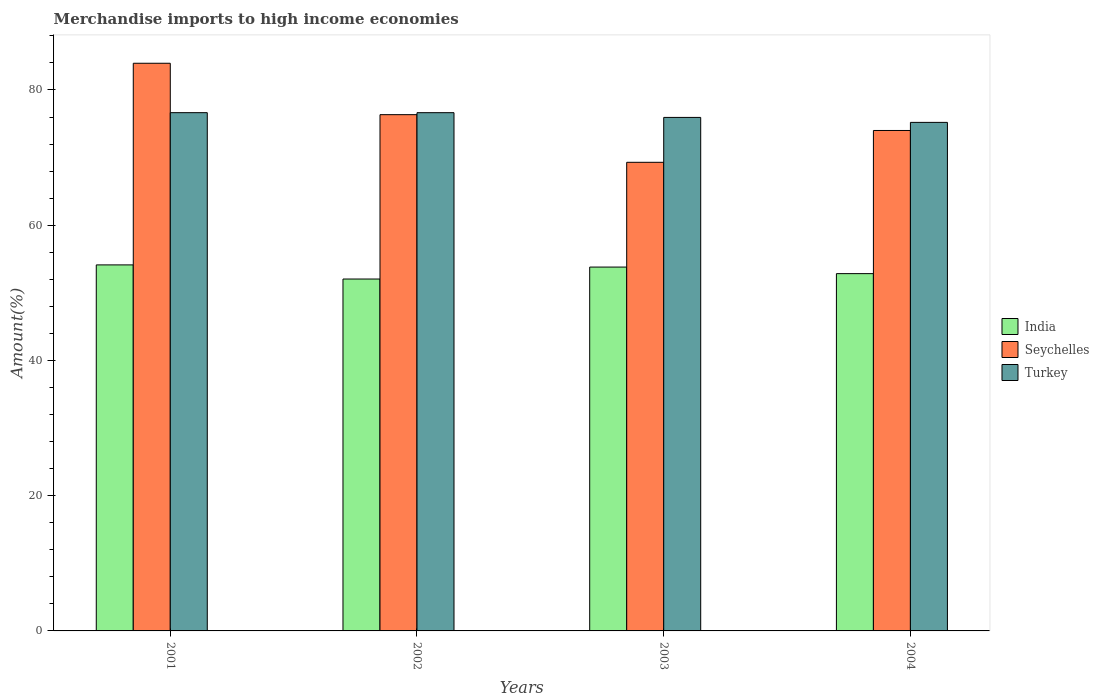How many different coloured bars are there?
Give a very brief answer. 3. How many groups of bars are there?
Provide a succinct answer. 4. How many bars are there on the 4th tick from the right?
Your response must be concise. 3. In how many cases, is the number of bars for a given year not equal to the number of legend labels?
Offer a very short reply. 0. What is the percentage of amount earned from merchandise imports in Turkey in 2001?
Offer a terse response. 76.65. Across all years, what is the maximum percentage of amount earned from merchandise imports in Turkey?
Ensure brevity in your answer.  76.65. Across all years, what is the minimum percentage of amount earned from merchandise imports in Seychelles?
Offer a very short reply. 69.31. In which year was the percentage of amount earned from merchandise imports in Turkey maximum?
Keep it short and to the point. 2001. What is the total percentage of amount earned from merchandise imports in Seychelles in the graph?
Offer a very short reply. 303.63. What is the difference between the percentage of amount earned from merchandise imports in Turkey in 2001 and that in 2004?
Ensure brevity in your answer.  1.44. What is the difference between the percentage of amount earned from merchandise imports in Turkey in 2002 and the percentage of amount earned from merchandise imports in India in 2004?
Your response must be concise. 23.81. What is the average percentage of amount earned from merchandise imports in Seychelles per year?
Make the answer very short. 75.91. In the year 2004, what is the difference between the percentage of amount earned from merchandise imports in Seychelles and percentage of amount earned from merchandise imports in India?
Give a very brief answer. 21.17. In how many years, is the percentage of amount earned from merchandise imports in Seychelles greater than 44 %?
Give a very brief answer. 4. What is the ratio of the percentage of amount earned from merchandise imports in India in 2001 to that in 2002?
Give a very brief answer. 1.04. Is the difference between the percentage of amount earned from merchandise imports in Seychelles in 2001 and 2002 greater than the difference between the percentage of amount earned from merchandise imports in India in 2001 and 2002?
Offer a very short reply. Yes. What is the difference between the highest and the second highest percentage of amount earned from merchandise imports in India?
Your answer should be compact. 0.32. What is the difference between the highest and the lowest percentage of amount earned from merchandise imports in India?
Provide a short and direct response. 2.09. In how many years, is the percentage of amount earned from merchandise imports in Turkey greater than the average percentage of amount earned from merchandise imports in Turkey taken over all years?
Make the answer very short. 2. Is the sum of the percentage of amount earned from merchandise imports in Seychelles in 2002 and 2004 greater than the maximum percentage of amount earned from merchandise imports in India across all years?
Offer a terse response. Yes. Is it the case that in every year, the sum of the percentage of amount earned from merchandise imports in Turkey and percentage of amount earned from merchandise imports in Seychelles is greater than the percentage of amount earned from merchandise imports in India?
Your answer should be very brief. Yes. How many bars are there?
Provide a succinct answer. 12. What is the difference between two consecutive major ticks on the Y-axis?
Your response must be concise. 20. Does the graph contain any zero values?
Your answer should be very brief. No. How are the legend labels stacked?
Give a very brief answer. Vertical. What is the title of the graph?
Your response must be concise. Merchandise imports to high income economies. What is the label or title of the Y-axis?
Provide a short and direct response. Amount(%). What is the Amount(%) in India in 2001?
Provide a short and direct response. 54.13. What is the Amount(%) in Seychelles in 2001?
Provide a succinct answer. 83.95. What is the Amount(%) of Turkey in 2001?
Keep it short and to the point. 76.65. What is the Amount(%) in India in 2002?
Ensure brevity in your answer.  52.04. What is the Amount(%) in Seychelles in 2002?
Provide a short and direct response. 76.35. What is the Amount(%) in Turkey in 2002?
Give a very brief answer. 76.65. What is the Amount(%) in India in 2003?
Provide a succinct answer. 53.81. What is the Amount(%) in Seychelles in 2003?
Your response must be concise. 69.31. What is the Amount(%) of Turkey in 2003?
Offer a very short reply. 75.95. What is the Amount(%) in India in 2004?
Ensure brevity in your answer.  52.84. What is the Amount(%) of Seychelles in 2004?
Offer a terse response. 74.01. What is the Amount(%) of Turkey in 2004?
Your answer should be very brief. 75.21. Across all years, what is the maximum Amount(%) in India?
Ensure brevity in your answer.  54.13. Across all years, what is the maximum Amount(%) of Seychelles?
Your answer should be compact. 83.95. Across all years, what is the maximum Amount(%) in Turkey?
Your answer should be very brief. 76.65. Across all years, what is the minimum Amount(%) in India?
Provide a short and direct response. 52.04. Across all years, what is the minimum Amount(%) in Seychelles?
Keep it short and to the point. 69.31. Across all years, what is the minimum Amount(%) of Turkey?
Keep it short and to the point. 75.21. What is the total Amount(%) of India in the graph?
Keep it short and to the point. 212.83. What is the total Amount(%) of Seychelles in the graph?
Make the answer very short. 303.63. What is the total Amount(%) in Turkey in the graph?
Ensure brevity in your answer.  304.45. What is the difference between the Amount(%) of India in 2001 and that in 2002?
Your response must be concise. 2.09. What is the difference between the Amount(%) in Seychelles in 2001 and that in 2002?
Offer a very short reply. 7.6. What is the difference between the Amount(%) in Turkey in 2001 and that in 2002?
Provide a succinct answer. 0. What is the difference between the Amount(%) in India in 2001 and that in 2003?
Your answer should be very brief. 0.32. What is the difference between the Amount(%) in Seychelles in 2001 and that in 2003?
Provide a short and direct response. 14.65. What is the difference between the Amount(%) in Turkey in 2001 and that in 2003?
Offer a terse response. 0.7. What is the difference between the Amount(%) of India in 2001 and that in 2004?
Keep it short and to the point. 1.29. What is the difference between the Amount(%) in Seychelles in 2001 and that in 2004?
Your answer should be very brief. 9.94. What is the difference between the Amount(%) in Turkey in 2001 and that in 2004?
Keep it short and to the point. 1.44. What is the difference between the Amount(%) in India in 2002 and that in 2003?
Offer a very short reply. -1.77. What is the difference between the Amount(%) in Seychelles in 2002 and that in 2003?
Offer a terse response. 7.05. What is the difference between the Amount(%) of Turkey in 2002 and that in 2003?
Your response must be concise. 0.7. What is the difference between the Amount(%) in India in 2002 and that in 2004?
Your response must be concise. -0.8. What is the difference between the Amount(%) of Seychelles in 2002 and that in 2004?
Give a very brief answer. 2.34. What is the difference between the Amount(%) of Turkey in 2002 and that in 2004?
Your answer should be very brief. 1.44. What is the difference between the Amount(%) in India in 2003 and that in 2004?
Provide a succinct answer. 0.97. What is the difference between the Amount(%) of Seychelles in 2003 and that in 2004?
Your answer should be compact. -4.71. What is the difference between the Amount(%) in Turkey in 2003 and that in 2004?
Offer a very short reply. 0.74. What is the difference between the Amount(%) of India in 2001 and the Amount(%) of Seychelles in 2002?
Keep it short and to the point. -22.22. What is the difference between the Amount(%) in India in 2001 and the Amount(%) in Turkey in 2002?
Offer a terse response. -22.51. What is the difference between the Amount(%) in Seychelles in 2001 and the Amount(%) in Turkey in 2002?
Keep it short and to the point. 7.31. What is the difference between the Amount(%) of India in 2001 and the Amount(%) of Seychelles in 2003?
Ensure brevity in your answer.  -15.17. What is the difference between the Amount(%) of India in 2001 and the Amount(%) of Turkey in 2003?
Your answer should be compact. -21.81. What is the difference between the Amount(%) in Seychelles in 2001 and the Amount(%) in Turkey in 2003?
Keep it short and to the point. 8.01. What is the difference between the Amount(%) of India in 2001 and the Amount(%) of Seychelles in 2004?
Give a very brief answer. -19.88. What is the difference between the Amount(%) in India in 2001 and the Amount(%) in Turkey in 2004?
Provide a short and direct response. -21.08. What is the difference between the Amount(%) of Seychelles in 2001 and the Amount(%) of Turkey in 2004?
Make the answer very short. 8.74. What is the difference between the Amount(%) in India in 2002 and the Amount(%) in Seychelles in 2003?
Make the answer very short. -17.26. What is the difference between the Amount(%) in India in 2002 and the Amount(%) in Turkey in 2003?
Offer a terse response. -23.9. What is the difference between the Amount(%) in Seychelles in 2002 and the Amount(%) in Turkey in 2003?
Offer a very short reply. 0.41. What is the difference between the Amount(%) in India in 2002 and the Amount(%) in Seychelles in 2004?
Keep it short and to the point. -21.97. What is the difference between the Amount(%) in India in 2002 and the Amount(%) in Turkey in 2004?
Offer a very short reply. -23.16. What is the difference between the Amount(%) of Seychelles in 2002 and the Amount(%) of Turkey in 2004?
Provide a short and direct response. 1.14. What is the difference between the Amount(%) of India in 2003 and the Amount(%) of Seychelles in 2004?
Give a very brief answer. -20.2. What is the difference between the Amount(%) in India in 2003 and the Amount(%) in Turkey in 2004?
Offer a terse response. -21.4. What is the difference between the Amount(%) in Seychelles in 2003 and the Amount(%) in Turkey in 2004?
Give a very brief answer. -5.9. What is the average Amount(%) in India per year?
Provide a short and direct response. 53.21. What is the average Amount(%) of Seychelles per year?
Your answer should be very brief. 75.91. What is the average Amount(%) of Turkey per year?
Offer a terse response. 76.11. In the year 2001, what is the difference between the Amount(%) in India and Amount(%) in Seychelles?
Give a very brief answer. -29.82. In the year 2001, what is the difference between the Amount(%) of India and Amount(%) of Turkey?
Your answer should be very brief. -22.52. In the year 2001, what is the difference between the Amount(%) of Seychelles and Amount(%) of Turkey?
Provide a succinct answer. 7.31. In the year 2002, what is the difference between the Amount(%) in India and Amount(%) in Seychelles?
Make the answer very short. -24.31. In the year 2002, what is the difference between the Amount(%) of India and Amount(%) of Turkey?
Give a very brief answer. -24.6. In the year 2002, what is the difference between the Amount(%) in Seychelles and Amount(%) in Turkey?
Give a very brief answer. -0.29. In the year 2003, what is the difference between the Amount(%) of India and Amount(%) of Seychelles?
Give a very brief answer. -15.49. In the year 2003, what is the difference between the Amount(%) in India and Amount(%) in Turkey?
Your answer should be compact. -22.13. In the year 2003, what is the difference between the Amount(%) of Seychelles and Amount(%) of Turkey?
Provide a short and direct response. -6.64. In the year 2004, what is the difference between the Amount(%) in India and Amount(%) in Seychelles?
Your answer should be very brief. -21.17. In the year 2004, what is the difference between the Amount(%) of India and Amount(%) of Turkey?
Ensure brevity in your answer.  -22.37. In the year 2004, what is the difference between the Amount(%) in Seychelles and Amount(%) in Turkey?
Keep it short and to the point. -1.2. What is the ratio of the Amount(%) in India in 2001 to that in 2002?
Offer a terse response. 1.04. What is the ratio of the Amount(%) in Seychelles in 2001 to that in 2002?
Keep it short and to the point. 1.1. What is the ratio of the Amount(%) in Turkey in 2001 to that in 2002?
Give a very brief answer. 1. What is the ratio of the Amount(%) in India in 2001 to that in 2003?
Provide a succinct answer. 1.01. What is the ratio of the Amount(%) of Seychelles in 2001 to that in 2003?
Offer a terse response. 1.21. What is the ratio of the Amount(%) in Turkey in 2001 to that in 2003?
Give a very brief answer. 1.01. What is the ratio of the Amount(%) in India in 2001 to that in 2004?
Offer a very short reply. 1.02. What is the ratio of the Amount(%) in Seychelles in 2001 to that in 2004?
Provide a short and direct response. 1.13. What is the ratio of the Amount(%) in Turkey in 2001 to that in 2004?
Your answer should be compact. 1.02. What is the ratio of the Amount(%) in India in 2002 to that in 2003?
Offer a terse response. 0.97. What is the ratio of the Amount(%) in Seychelles in 2002 to that in 2003?
Offer a terse response. 1.1. What is the ratio of the Amount(%) in Turkey in 2002 to that in 2003?
Ensure brevity in your answer.  1.01. What is the ratio of the Amount(%) of India in 2002 to that in 2004?
Your answer should be compact. 0.98. What is the ratio of the Amount(%) in Seychelles in 2002 to that in 2004?
Your response must be concise. 1.03. What is the ratio of the Amount(%) in Turkey in 2002 to that in 2004?
Make the answer very short. 1.02. What is the ratio of the Amount(%) of India in 2003 to that in 2004?
Give a very brief answer. 1.02. What is the ratio of the Amount(%) of Seychelles in 2003 to that in 2004?
Ensure brevity in your answer.  0.94. What is the ratio of the Amount(%) of Turkey in 2003 to that in 2004?
Give a very brief answer. 1.01. What is the difference between the highest and the second highest Amount(%) of India?
Your response must be concise. 0.32. What is the difference between the highest and the second highest Amount(%) of Seychelles?
Offer a terse response. 7.6. What is the difference between the highest and the second highest Amount(%) of Turkey?
Provide a short and direct response. 0. What is the difference between the highest and the lowest Amount(%) of India?
Ensure brevity in your answer.  2.09. What is the difference between the highest and the lowest Amount(%) in Seychelles?
Offer a very short reply. 14.65. What is the difference between the highest and the lowest Amount(%) in Turkey?
Provide a succinct answer. 1.44. 